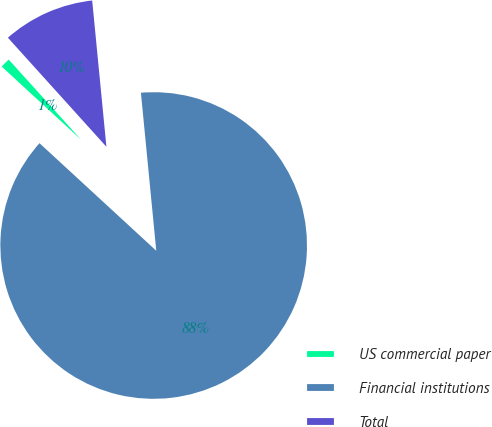Convert chart. <chart><loc_0><loc_0><loc_500><loc_500><pie_chart><fcel>US commercial paper<fcel>Financial institutions<fcel>Total<nl><fcel>1.46%<fcel>88.39%<fcel>10.15%<nl></chart> 